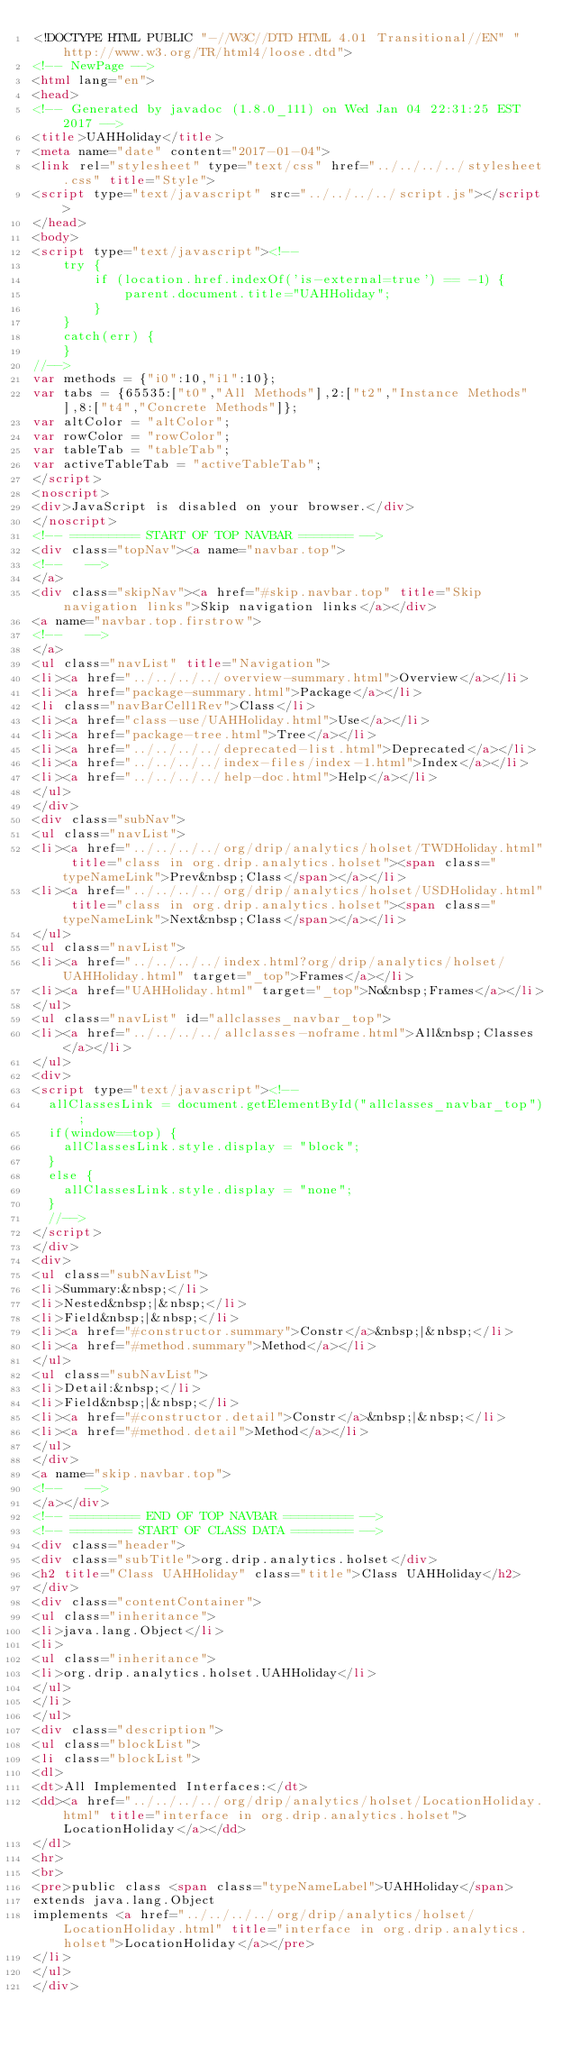<code> <loc_0><loc_0><loc_500><loc_500><_HTML_><!DOCTYPE HTML PUBLIC "-//W3C//DTD HTML 4.01 Transitional//EN" "http://www.w3.org/TR/html4/loose.dtd">
<!-- NewPage -->
<html lang="en">
<head>
<!-- Generated by javadoc (1.8.0_111) on Wed Jan 04 22:31:25 EST 2017 -->
<title>UAHHoliday</title>
<meta name="date" content="2017-01-04">
<link rel="stylesheet" type="text/css" href="../../../../stylesheet.css" title="Style">
<script type="text/javascript" src="../../../../script.js"></script>
</head>
<body>
<script type="text/javascript"><!--
    try {
        if (location.href.indexOf('is-external=true') == -1) {
            parent.document.title="UAHHoliday";
        }
    }
    catch(err) {
    }
//-->
var methods = {"i0":10,"i1":10};
var tabs = {65535:["t0","All Methods"],2:["t2","Instance Methods"],8:["t4","Concrete Methods"]};
var altColor = "altColor";
var rowColor = "rowColor";
var tableTab = "tableTab";
var activeTableTab = "activeTableTab";
</script>
<noscript>
<div>JavaScript is disabled on your browser.</div>
</noscript>
<!-- ========= START OF TOP NAVBAR ======= -->
<div class="topNav"><a name="navbar.top">
<!--   -->
</a>
<div class="skipNav"><a href="#skip.navbar.top" title="Skip navigation links">Skip navigation links</a></div>
<a name="navbar.top.firstrow">
<!--   -->
</a>
<ul class="navList" title="Navigation">
<li><a href="../../../../overview-summary.html">Overview</a></li>
<li><a href="package-summary.html">Package</a></li>
<li class="navBarCell1Rev">Class</li>
<li><a href="class-use/UAHHoliday.html">Use</a></li>
<li><a href="package-tree.html">Tree</a></li>
<li><a href="../../../../deprecated-list.html">Deprecated</a></li>
<li><a href="../../../../index-files/index-1.html">Index</a></li>
<li><a href="../../../../help-doc.html">Help</a></li>
</ul>
</div>
<div class="subNav">
<ul class="navList">
<li><a href="../../../../org/drip/analytics/holset/TWDHoliday.html" title="class in org.drip.analytics.holset"><span class="typeNameLink">Prev&nbsp;Class</span></a></li>
<li><a href="../../../../org/drip/analytics/holset/USDHoliday.html" title="class in org.drip.analytics.holset"><span class="typeNameLink">Next&nbsp;Class</span></a></li>
</ul>
<ul class="navList">
<li><a href="../../../../index.html?org/drip/analytics/holset/UAHHoliday.html" target="_top">Frames</a></li>
<li><a href="UAHHoliday.html" target="_top">No&nbsp;Frames</a></li>
</ul>
<ul class="navList" id="allclasses_navbar_top">
<li><a href="../../../../allclasses-noframe.html">All&nbsp;Classes</a></li>
</ul>
<div>
<script type="text/javascript"><!--
  allClassesLink = document.getElementById("allclasses_navbar_top");
  if(window==top) {
    allClassesLink.style.display = "block";
  }
  else {
    allClassesLink.style.display = "none";
  }
  //-->
</script>
</div>
<div>
<ul class="subNavList">
<li>Summary:&nbsp;</li>
<li>Nested&nbsp;|&nbsp;</li>
<li>Field&nbsp;|&nbsp;</li>
<li><a href="#constructor.summary">Constr</a>&nbsp;|&nbsp;</li>
<li><a href="#method.summary">Method</a></li>
</ul>
<ul class="subNavList">
<li>Detail:&nbsp;</li>
<li>Field&nbsp;|&nbsp;</li>
<li><a href="#constructor.detail">Constr</a>&nbsp;|&nbsp;</li>
<li><a href="#method.detail">Method</a></li>
</ul>
</div>
<a name="skip.navbar.top">
<!--   -->
</a></div>
<!-- ========= END OF TOP NAVBAR ========= -->
<!-- ======== START OF CLASS DATA ======== -->
<div class="header">
<div class="subTitle">org.drip.analytics.holset</div>
<h2 title="Class UAHHoliday" class="title">Class UAHHoliday</h2>
</div>
<div class="contentContainer">
<ul class="inheritance">
<li>java.lang.Object</li>
<li>
<ul class="inheritance">
<li>org.drip.analytics.holset.UAHHoliday</li>
</ul>
</li>
</ul>
<div class="description">
<ul class="blockList">
<li class="blockList">
<dl>
<dt>All Implemented Interfaces:</dt>
<dd><a href="../../../../org/drip/analytics/holset/LocationHoliday.html" title="interface in org.drip.analytics.holset">LocationHoliday</a></dd>
</dl>
<hr>
<br>
<pre>public class <span class="typeNameLabel">UAHHoliday</span>
extends java.lang.Object
implements <a href="../../../../org/drip/analytics/holset/LocationHoliday.html" title="interface in org.drip.analytics.holset">LocationHoliday</a></pre>
</li>
</ul>
</div></code> 